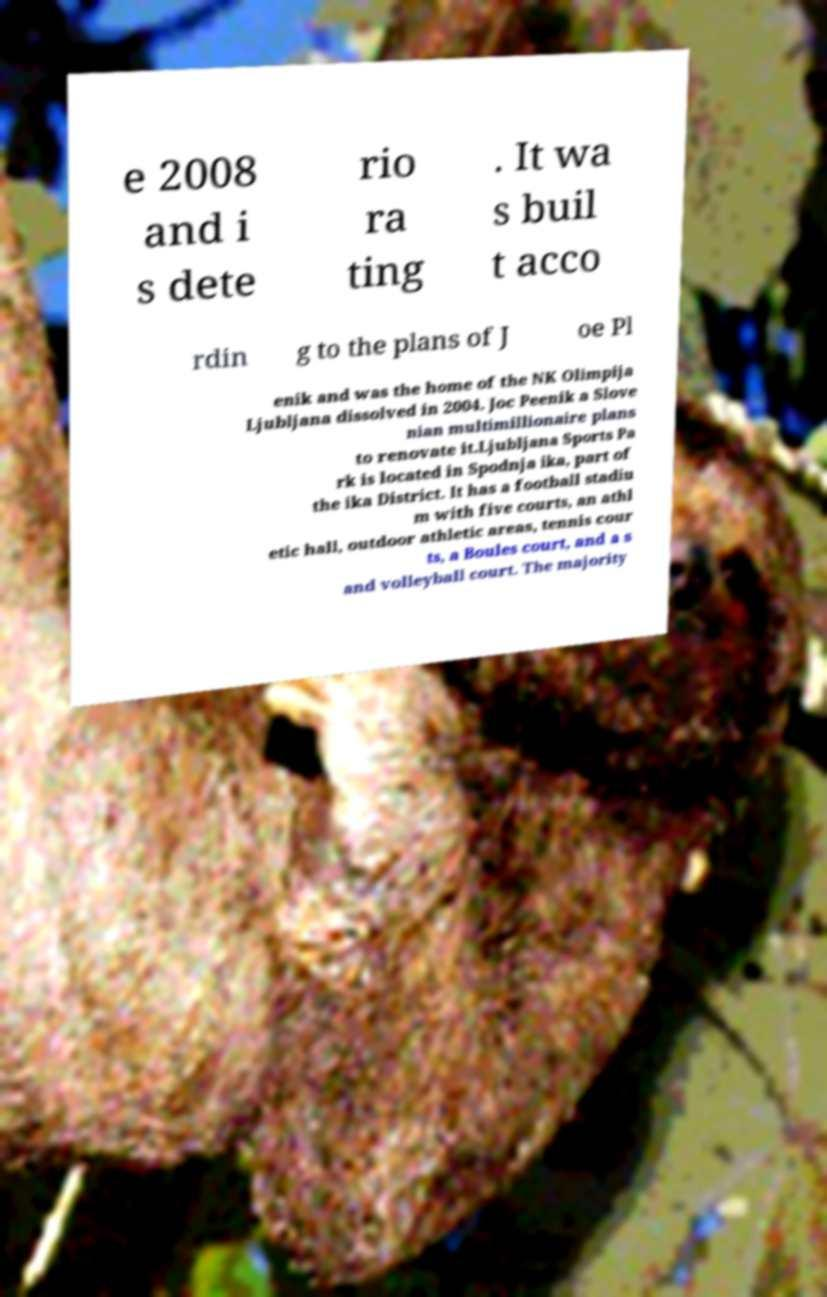Please identify and transcribe the text found in this image. e 2008 and i s dete rio ra ting . It wa s buil t acco rdin g to the plans of J oe Pl enik and was the home of the NK Olimpija Ljubljana dissolved in 2004. Joc Peenik a Slove nian multimillionaire plans to renovate it.Ljubljana Sports Pa rk is located in Spodnja ika, part of the ika District. It has a football stadiu m with five courts, an athl etic hall, outdoor athletic areas, tennis cour ts, a Boules court, and a s and volleyball court. The majority 